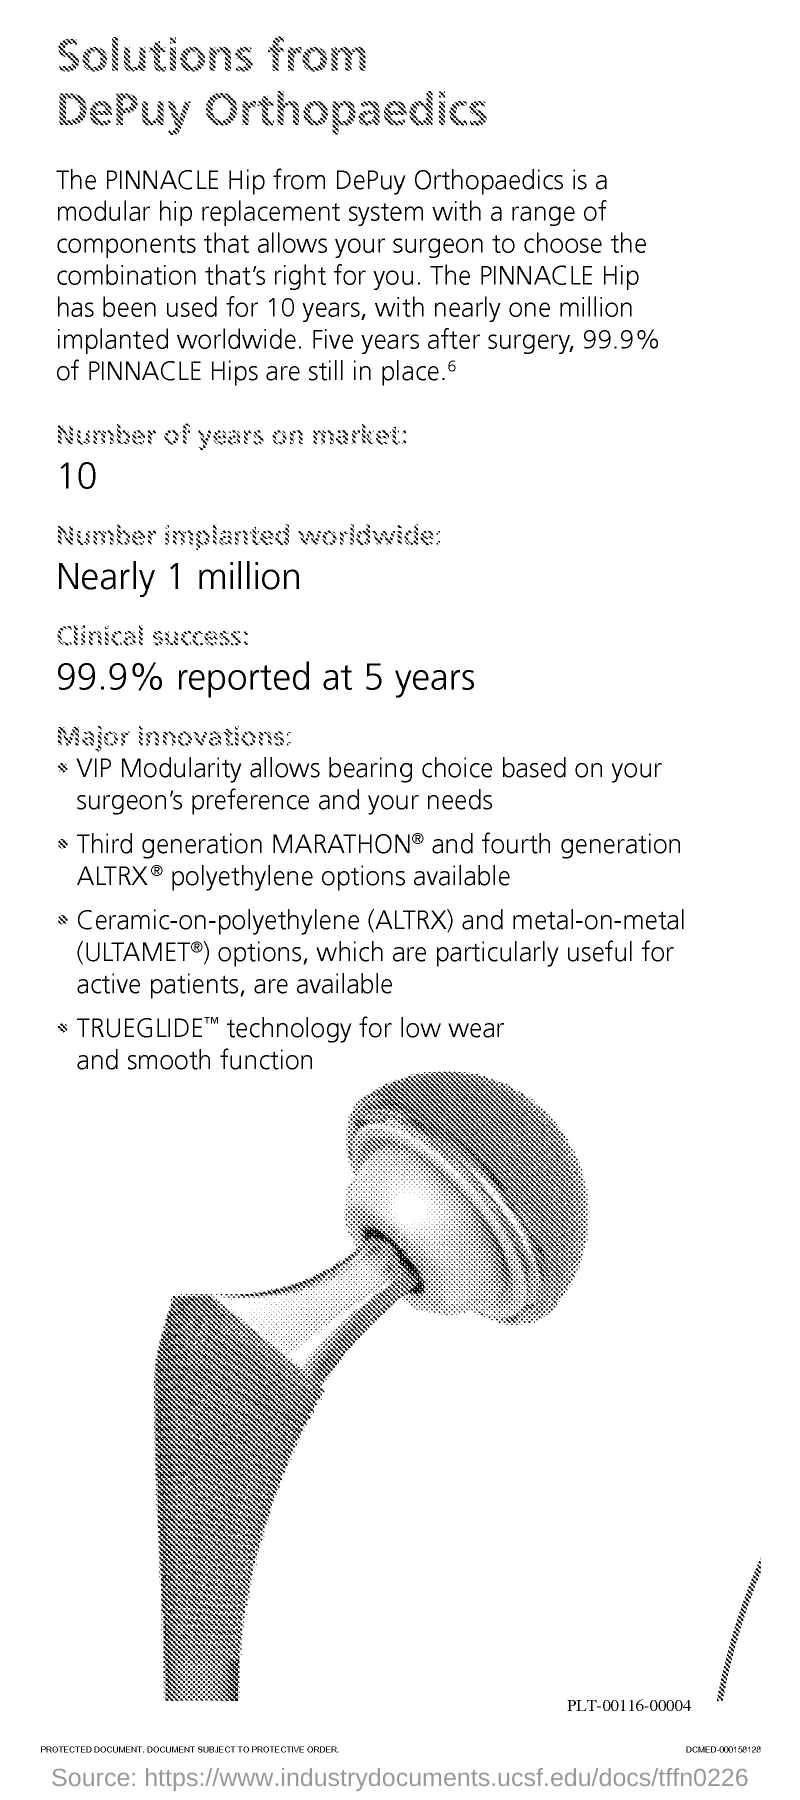What is the number of years of the PINNACLE Hip on the market?
Make the answer very short. 10. How many numbers of PINNACLE Hip is implanted worldwide?
Give a very brief answer. Nearly 1 million. What is the clinical success percent of the PINNACLE Hip?
Provide a short and direct response. 99.9% reported at 5 years. 